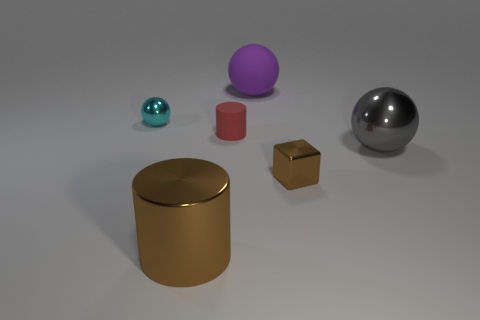What number of rubber things are big balls or tiny spheres?
Your response must be concise. 1. There is a big metal thing that is the same shape as the large rubber thing; what is its color?
Your answer should be compact. Gray. Are any cyan things visible?
Make the answer very short. Yes. Does the ball left of the purple object have the same material as the brown object right of the tiny matte thing?
Make the answer very short. Yes. What shape is the tiny metal object that is the same color as the shiny cylinder?
Keep it short and to the point. Cube. What number of things are matte objects that are right of the small red rubber thing or objects behind the small brown block?
Offer a very short reply. 4. Does the small metallic object on the right side of the cyan shiny sphere have the same color as the large ball that is behind the tiny shiny ball?
Offer a terse response. No. There is a thing that is both behind the block and to the left of the red object; what is its shape?
Offer a very short reply. Sphere. There is a shiny object that is the same size as the block; what is its color?
Offer a terse response. Cyan. Are there any other small blocks that have the same color as the metal block?
Offer a terse response. No. 